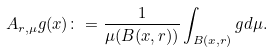Convert formula to latex. <formula><loc_0><loc_0><loc_500><loc_500>A _ { r , \mu } g ( x ) \colon = \frac { 1 } { \mu ( B ( x , r ) ) } \int _ { B ( x , r ) } g d \mu .</formula> 